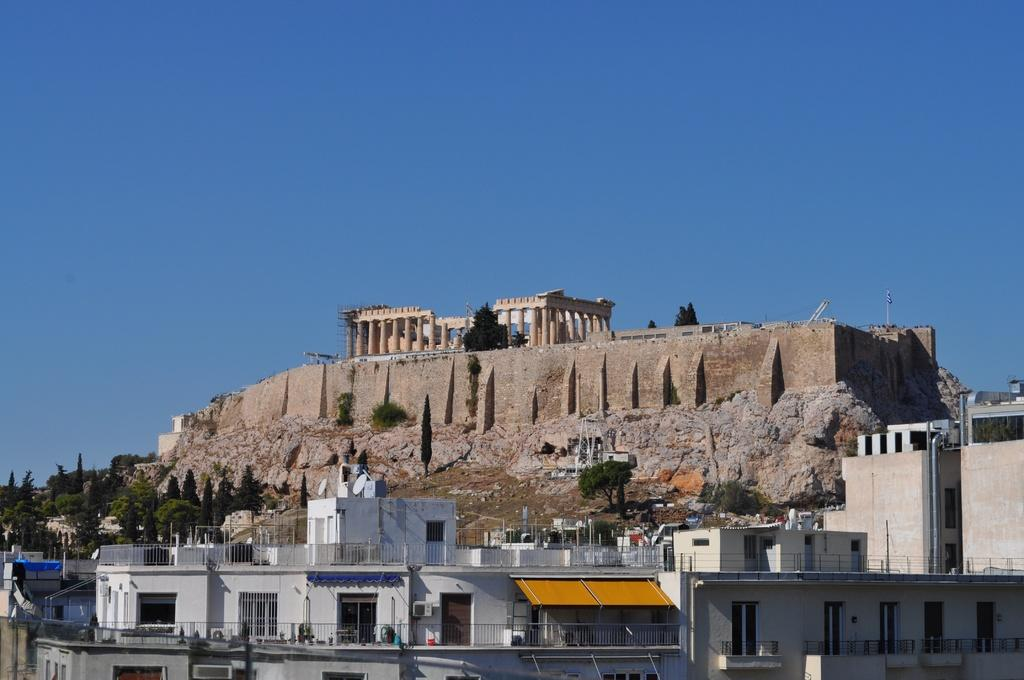What type of structures are present in the image? There are buildings with windows and doors in the image. What architectural features can be seen in the image? There are railings, a fort, and pillars visible in the image. What type of vegetation is visible in the background of the image? There are trees visible in the background of the image. What part of the natural environment is visible in the image? The sky is visible in the image. Can you tell me how many bikes are parked near the fort in the image? There are no bikes present in the image; it only features buildings, railings, trees, and the sky. 